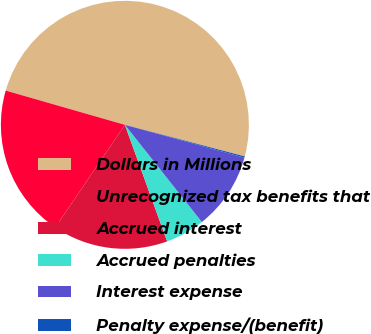Convert chart to OTSL. <chart><loc_0><loc_0><loc_500><loc_500><pie_chart><fcel>Dollars in Millions<fcel>Unrecognized tax benefits that<fcel>Accrued interest<fcel>Accrued penalties<fcel>Interest expense<fcel>Penalty expense/(benefit)<nl><fcel>49.65%<fcel>19.97%<fcel>15.02%<fcel>5.12%<fcel>10.07%<fcel>0.17%<nl></chart> 